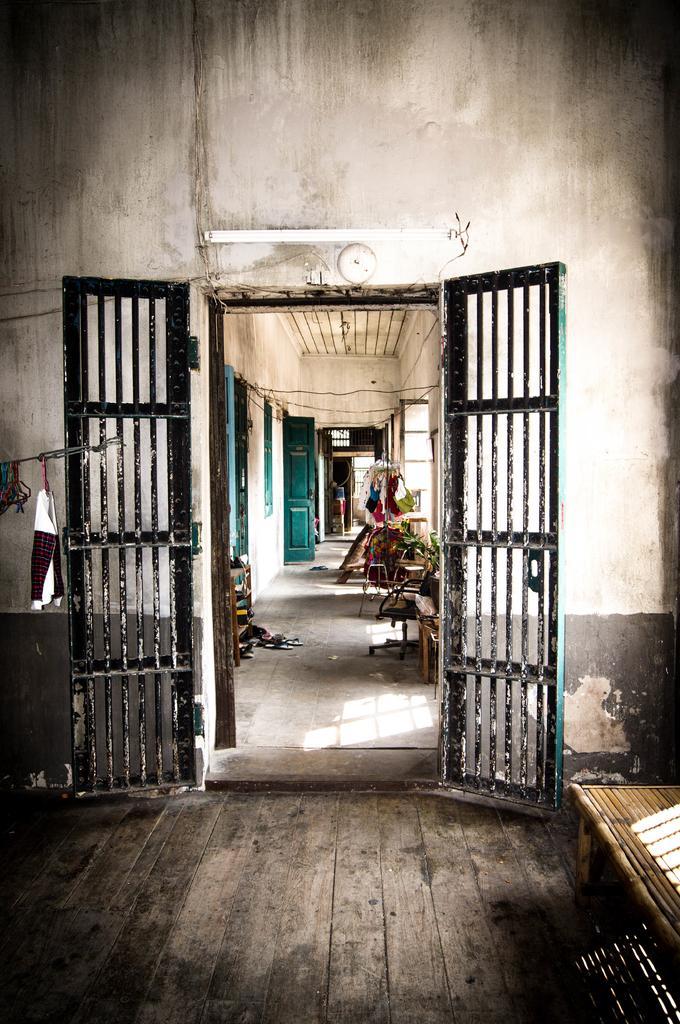Could you give a brief overview of what you see in this image? It is an edited image,there is a door and inside the door there are many houses in a compartment,the doors of the houses are in green color. 